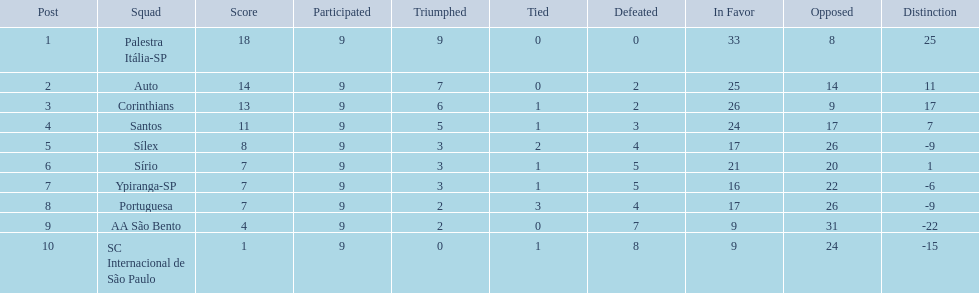What were the top three amounts of games won for 1926 in brazilian football season? 9, 7, 6. What were the top amount of games won for 1926 in brazilian football season? 9. What team won the top amount of games Palestra Itália-SP. 